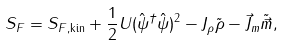<formula> <loc_0><loc_0><loc_500><loc_500>S _ { F } = S _ { F , \text {kin} } + \frac { 1 } { 2 } U ( \hat { \psi } ^ { \dagger } \hat { \psi } ) ^ { 2 } - J _ { \rho } \tilde { \rho } - \vec { J } _ { m } \tilde { \vec { m } } ,</formula> 